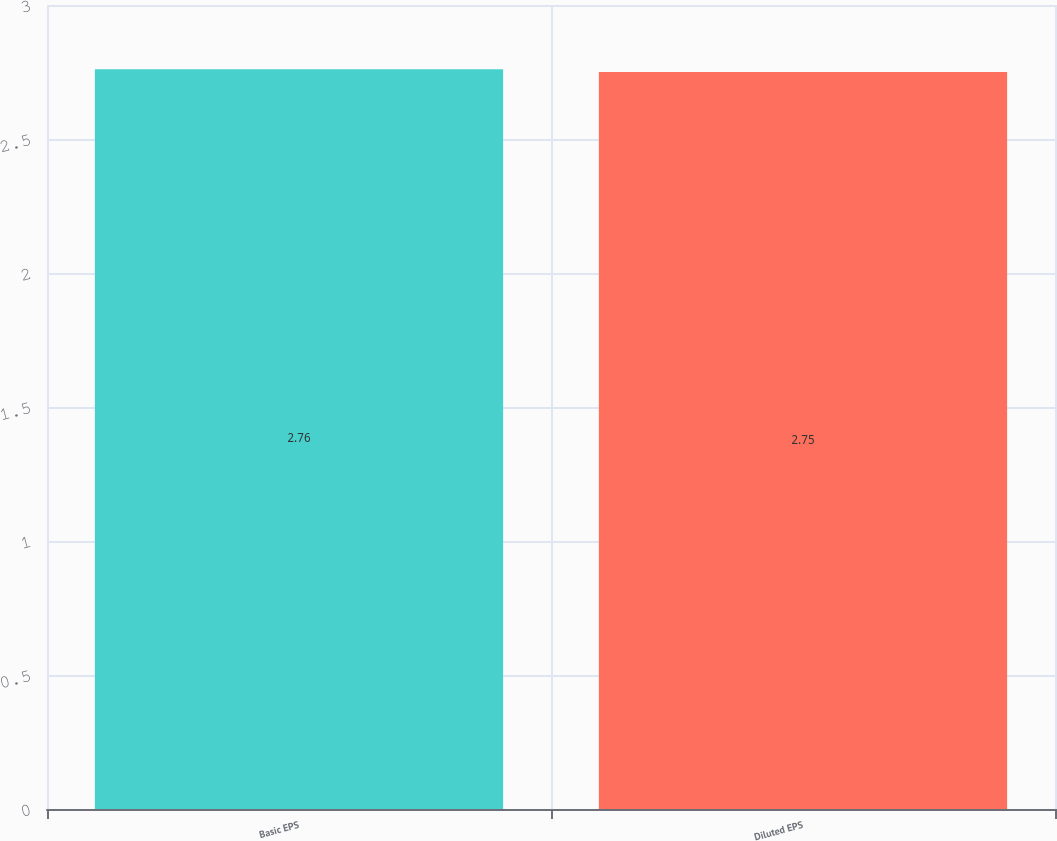<chart> <loc_0><loc_0><loc_500><loc_500><bar_chart><fcel>Basic EPS<fcel>Diluted EPS<nl><fcel>2.76<fcel>2.75<nl></chart> 